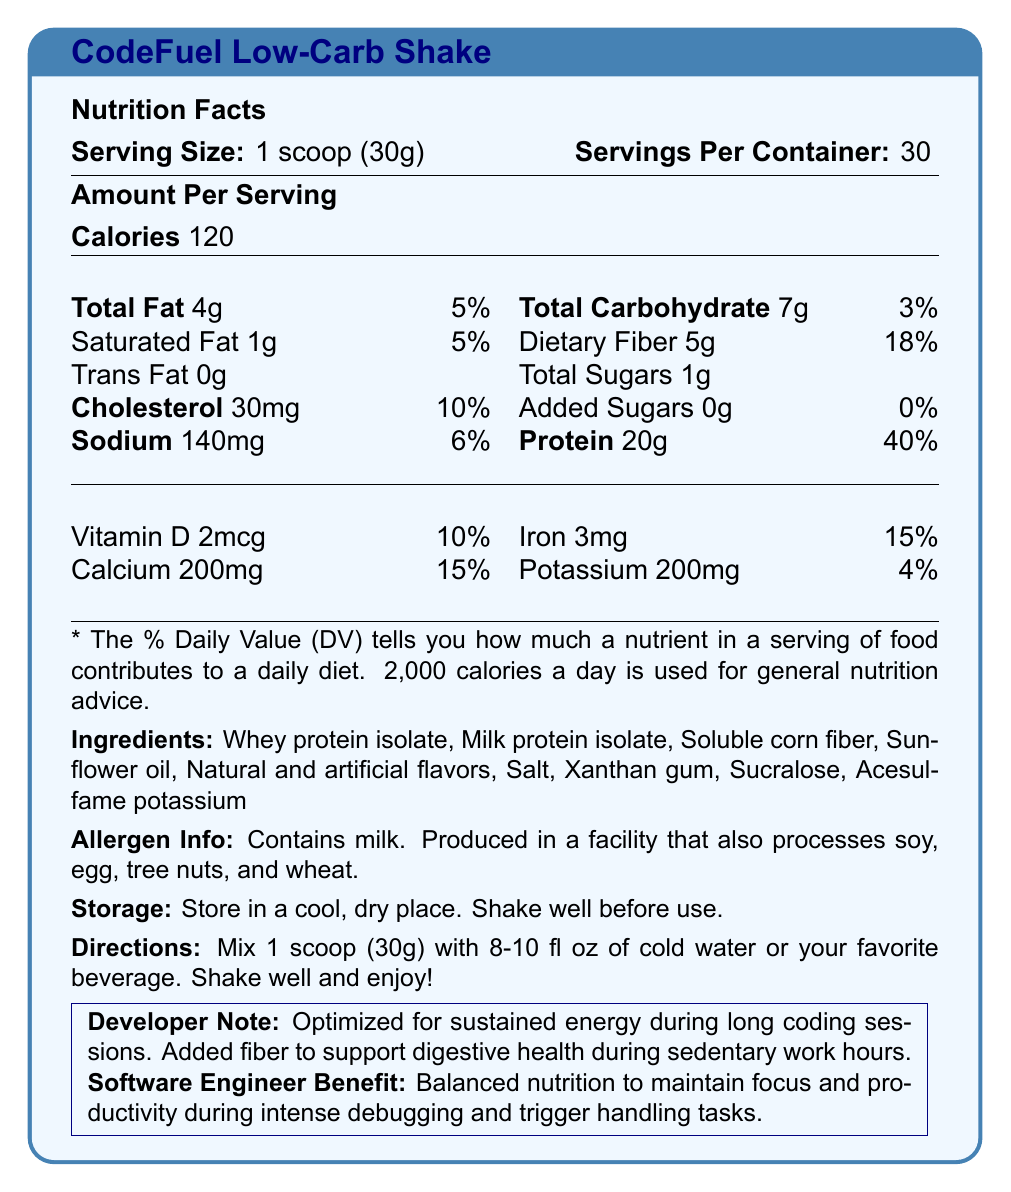what is the serving size of the CodeFuel Low-Carb Shake? The document clearly mentions "Serving Size: 1 scoop (30g)" under the Nutrition Facts section.
Answer: 1 scoop (30g) how many calories are in one serving of the shake? The Calories section lists "Calories 120" as the amount per serving.
Answer: 120 what is the total fat content per serving? The Total Fat section indicates "Total Fat 4g" under the Amount Per Serving.
Answer: 4g what are the directions for preparing the shake? The Directions section provides these instructions.
Answer: Mix 1 scoop (30g) with 8-10 fl oz of cold water or your favorite beverage. Shake well and enjoy! what is the amount of dietary fiber per serving, and what percentage of the daily value does it represent? The document lists "Dietary Fiber 5g" and "18%" under Total Carbohydrate.
Answer: 5g, 18% which ingredient is listed first? Under the Ingredients section, Whey protein isolate is listed first.
Answer: Whey protein isolate how much protein is in one serving? A. 15g B. 18g C. 20g D. 25g The Protein section notes "Protein 20g" as the amount per serving.
Answer: C. 20g how much sodium is in each serving? A. 100mg B. 140mg C. 200mg D. 250mg The Sodium section indicates "Sodium 140mg" as the per serving amount.
Answer: B. 140mg is there any added sugar in this shake? The Total Sugars section states "Added Sugars 0g 0%," indicating no added sugars.
Answer: No does this product contain any allergens? The Allergen Info section mentions that the product contains milk and is produced in a facility that processes soy, egg, tree nuts, and wheat.
Answer: Yes Who is the intended primary audience for this shake? The Software Engineer Benefit section specifies benefits tailored for software engineers, such as balanced nutrition to maintain focus during debugging and trigger handling tasks.
Answer: Software engineers can we determine the flavor of the shake from the document? The document lists "Natural and artificial flavors" but does not specify the exact flavor of the shake.
Answer: No summarize the main idea of the document. The document presents detailed nutrition facts, ingredients, allergen information, directions for use, and specific benefits for software engineers.
Answer: The CodeFuel Low-Carb Shake is a meal replacement shake optimized for software engineers, providing balanced nutrition, high protein, low carbohydrates, and added fiber to support focus, productivity, and digestive health during long coding sessions. It contains 120 calories, 20g of protein, and 5g of dietary fiber per serving, along with various vitamins and minerals. 